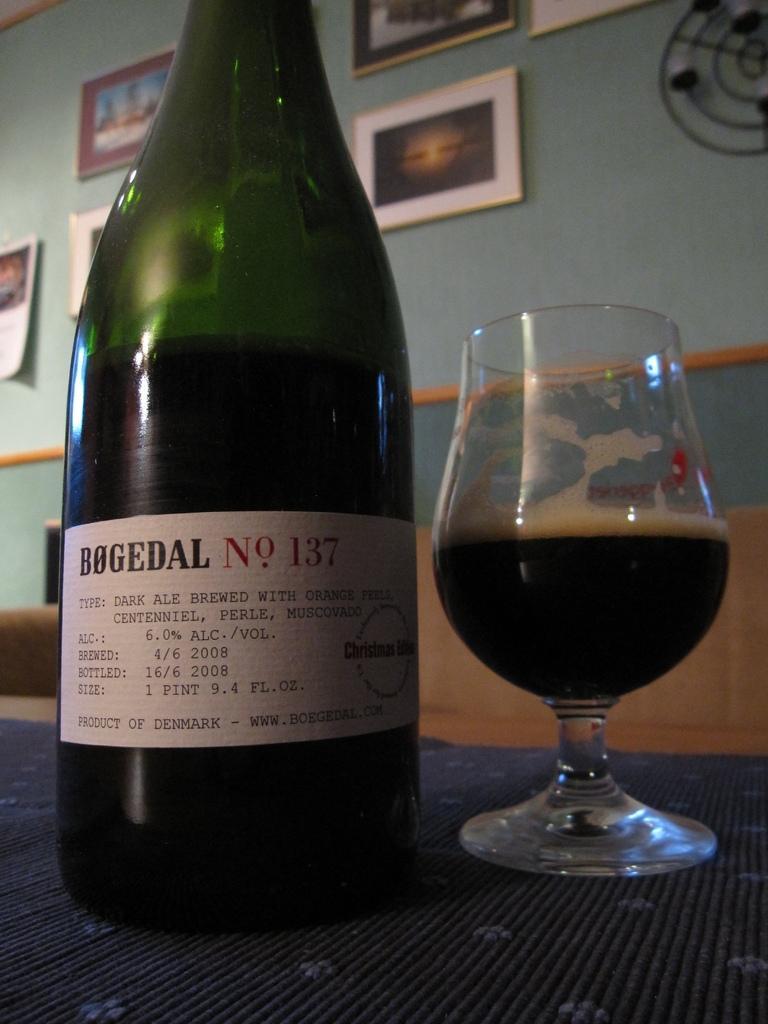In one or two sentences, can you explain what this image depicts? In this image i can see a bottle and a glass on a table at the back ground i can see few frames attached to a wall. 